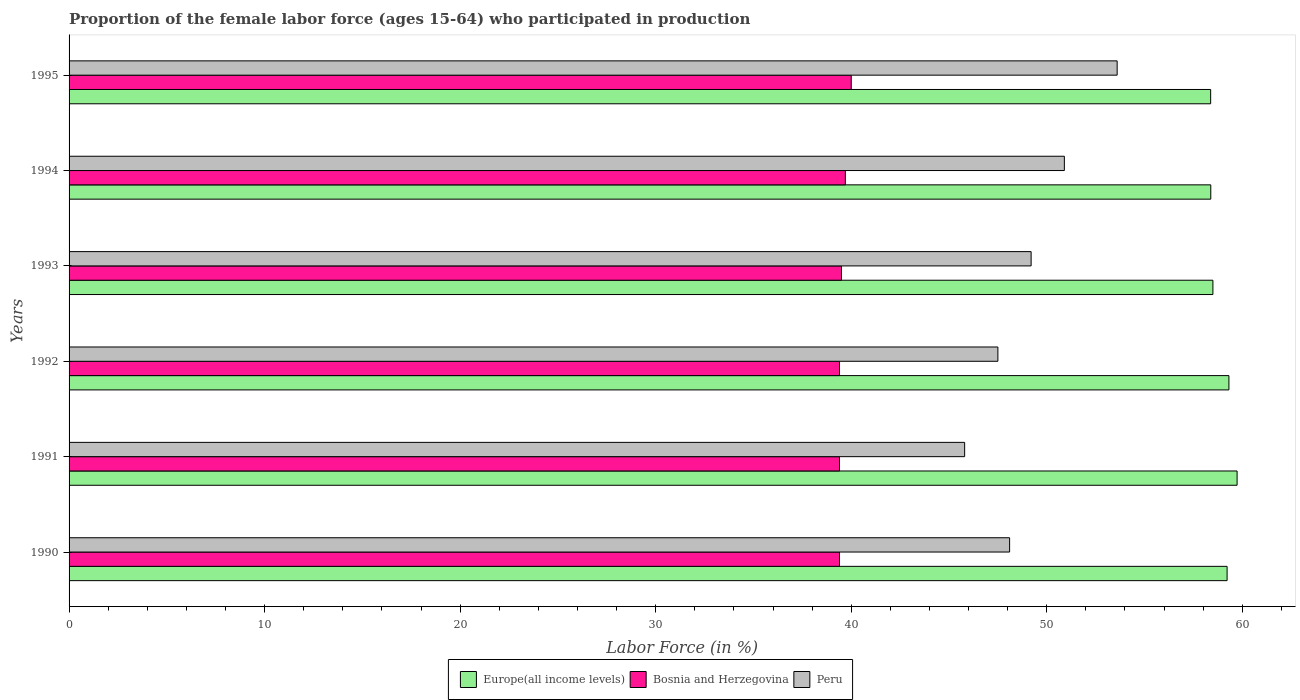How many different coloured bars are there?
Offer a very short reply. 3. How many groups of bars are there?
Ensure brevity in your answer.  6. Are the number of bars on each tick of the Y-axis equal?
Make the answer very short. Yes. How many bars are there on the 1st tick from the top?
Give a very brief answer. 3. What is the proportion of the female labor force who participated in production in Europe(all income levels) in 1993?
Ensure brevity in your answer.  58.5. Across all years, what is the maximum proportion of the female labor force who participated in production in Europe(all income levels)?
Offer a very short reply. 59.73. Across all years, what is the minimum proportion of the female labor force who participated in production in Bosnia and Herzegovina?
Keep it short and to the point. 39.4. In which year was the proportion of the female labor force who participated in production in Bosnia and Herzegovina minimum?
Offer a terse response. 1990. What is the total proportion of the female labor force who participated in production in Europe(all income levels) in the graph?
Offer a terse response. 353.54. What is the difference between the proportion of the female labor force who participated in production in Europe(all income levels) in 1992 and that in 1995?
Your answer should be very brief. 0.93. What is the difference between the proportion of the female labor force who participated in production in Peru in 1992 and the proportion of the female labor force who participated in production in Bosnia and Herzegovina in 1991?
Provide a short and direct response. 8.1. What is the average proportion of the female labor force who participated in production in Bosnia and Herzegovina per year?
Provide a short and direct response. 39.57. In the year 1994, what is the difference between the proportion of the female labor force who participated in production in Bosnia and Herzegovina and proportion of the female labor force who participated in production in Europe(all income levels)?
Make the answer very short. -18.69. In how many years, is the proportion of the female labor force who participated in production in Europe(all income levels) greater than 32 %?
Offer a terse response. 6. What is the ratio of the proportion of the female labor force who participated in production in Bosnia and Herzegovina in 1990 to that in 1995?
Make the answer very short. 0.99. Is the proportion of the female labor force who participated in production in Bosnia and Herzegovina in 1990 less than that in 1991?
Ensure brevity in your answer.  No. Is the difference between the proportion of the female labor force who participated in production in Bosnia and Herzegovina in 1990 and 1991 greater than the difference between the proportion of the female labor force who participated in production in Europe(all income levels) in 1990 and 1991?
Provide a short and direct response. Yes. What is the difference between the highest and the second highest proportion of the female labor force who participated in production in Europe(all income levels)?
Ensure brevity in your answer.  0.42. What is the difference between the highest and the lowest proportion of the female labor force who participated in production in Peru?
Your answer should be compact. 7.8. Is the sum of the proportion of the female labor force who participated in production in Peru in 1994 and 1995 greater than the maximum proportion of the female labor force who participated in production in Bosnia and Herzegovina across all years?
Provide a succinct answer. Yes. What does the 1st bar from the top in 1992 represents?
Offer a terse response. Peru. What does the 2nd bar from the bottom in 1990 represents?
Offer a very short reply. Bosnia and Herzegovina. How many bars are there?
Provide a short and direct response. 18. Are all the bars in the graph horizontal?
Your response must be concise. Yes. How many years are there in the graph?
Offer a terse response. 6. What is the difference between two consecutive major ticks on the X-axis?
Your answer should be very brief. 10. Does the graph contain any zero values?
Provide a short and direct response. No. What is the title of the graph?
Keep it short and to the point. Proportion of the female labor force (ages 15-64) who participated in production. Does "East Asia (developing only)" appear as one of the legend labels in the graph?
Provide a succinct answer. No. What is the label or title of the Y-axis?
Your response must be concise. Years. What is the Labor Force (in %) in Europe(all income levels) in 1990?
Your answer should be compact. 59.22. What is the Labor Force (in %) in Bosnia and Herzegovina in 1990?
Provide a short and direct response. 39.4. What is the Labor Force (in %) in Peru in 1990?
Offer a terse response. 48.1. What is the Labor Force (in %) of Europe(all income levels) in 1991?
Give a very brief answer. 59.73. What is the Labor Force (in %) in Bosnia and Herzegovina in 1991?
Your answer should be very brief. 39.4. What is the Labor Force (in %) in Peru in 1991?
Offer a terse response. 45.8. What is the Labor Force (in %) of Europe(all income levels) in 1992?
Your answer should be compact. 59.32. What is the Labor Force (in %) in Bosnia and Herzegovina in 1992?
Offer a very short reply. 39.4. What is the Labor Force (in %) of Peru in 1992?
Your response must be concise. 47.5. What is the Labor Force (in %) in Europe(all income levels) in 1993?
Keep it short and to the point. 58.5. What is the Labor Force (in %) of Bosnia and Herzegovina in 1993?
Make the answer very short. 39.5. What is the Labor Force (in %) of Peru in 1993?
Your answer should be compact. 49.2. What is the Labor Force (in %) of Europe(all income levels) in 1994?
Provide a succinct answer. 58.39. What is the Labor Force (in %) in Bosnia and Herzegovina in 1994?
Your answer should be compact. 39.7. What is the Labor Force (in %) of Peru in 1994?
Offer a terse response. 50.9. What is the Labor Force (in %) of Europe(all income levels) in 1995?
Provide a succinct answer. 58.38. What is the Labor Force (in %) in Peru in 1995?
Provide a short and direct response. 53.6. Across all years, what is the maximum Labor Force (in %) of Europe(all income levels)?
Keep it short and to the point. 59.73. Across all years, what is the maximum Labor Force (in %) of Bosnia and Herzegovina?
Ensure brevity in your answer.  40. Across all years, what is the maximum Labor Force (in %) of Peru?
Make the answer very short. 53.6. Across all years, what is the minimum Labor Force (in %) in Europe(all income levels)?
Provide a short and direct response. 58.38. Across all years, what is the minimum Labor Force (in %) of Bosnia and Herzegovina?
Keep it short and to the point. 39.4. Across all years, what is the minimum Labor Force (in %) of Peru?
Ensure brevity in your answer.  45.8. What is the total Labor Force (in %) of Europe(all income levels) in the graph?
Keep it short and to the point. 353.54. What is the total Labor Force (in %) in Bosnia and Herzegovina in the graph?
Ensure brevity in your answer.  237.4. What is the total Labor Force (in %) in Peru in the graph?
Give a very brief answer. 295.1. What is the difference between the Labor Force (in %) in Europe(all income levels) in 1990 and that in 1991?
Your response must be concise. -0.51. What is the difference between the Labor Force (in %) of Europe(all income levels) in 1990 and that in 1992?
Offer a very short reply. -0.09. What is the difference between the Labor Force (in %) in Bosnia and Herzegovina in 1990 and that in 1992?
Provide a succinct answer. 0. What is the difference between the Labor Force (in %) of Europe(all income levels) in 1990 and that in 1993?
Give a very brief answer. 0.73. What is the difference between the Labor Force (in %) of Bosnia and Herzegovina in 1990 and that in 1993?
Provide a succinct answer. -0.1. What is the difference between the Labor Force (in %) in Peru in 1990 and that in 1993?
Give a very brief answer. -1.1. What is the difference between the Labor Force (in %) of Europe(all income levels) in 1990 and that in 1994?
Your answer should be compact. 0.83. What is the difference between the Labor Force (in %) of Europe(all income levels) in 1990 and that in 1995?
Your answer should be very brief. 0.84. What is the difference between the Labor Force (in %) of Peru in 1990 and that in 1995?
Keep it short and to the point. -5.5. What is the difference between the Labor Force (in %) of Europe(all income levels) in 1991 and that in 1992?
Your answer should be very brief. 0.42. What is the difference between the Labor Force (in %) of Bosnia and Herzegovina in 1991 and that in 1992?
Offer a terse response. 0. What is the difference between the Labor Force (in %) in Peru in 1991 and that in 1992?
Your answer should be very brief. -1.7. What is the difference between the Labor Force (in %) of Europe(all income levels) in 1991 and that in 1993?
Offer a very short reply. 1.24. What is the difference between the Labor Force (in %) in Peru in 1991 and that in 1993?
Offer a terse response. -3.4. What is the difference between the Labor Force (in %) in Europe(all income levels) in 1991 and that in 1994?
Provide a succinct answer. 1.35. What is the difference between the Labor Force (in %) in Bosnia and Herzegovina in 1991 and that in 1994?
Make the answer very short. -0.3. What is the difference between the Labor Force (in %) of Europe(all income levels) in 1991 and that in 1995?
Your answer should be compact. 1.35. What is the difference between the Labor Force (in %) of Europe(all income levels) in 1992 and that in 1993?
Provide a short and direct response. 0.82. What is the difference between the Labor Force (in %) in Bosnia and Herzegovina in 1992 and that in 1993?
Your answer should be compact. -0.1. What is the difference between the Labor Force (in %) of Peru in 1992 and that in 1993?
Ensure brevity in your answer.  -1.7. What is the difference between the Labor Force (in %) of Europe(all income levels) in 1992 and that in 1994?
Offer a very short reply. 0.93. What is the difference between the Labor Force (in %) in Peru in 1992 and that in 1994?
Ensure brevity in your answer.  -3.4. What is the difference between the Labor Force (in %) in Europe(all income levels) in 1992 and that in 1995?
Provide a short and direct response. 0.93. What is the difference between the Labor Force (in %) in Bosnia and Herzegovina in 1992 and that in 1995?
Your response must be concise. -0.6. What is the difference between the Labor Force (in %) in Europe(all income levels) in 1993 and that in 1994?
Make the answer very short. 0.11. What is the difference between the Labor Force (in %) of Europe(all income levels) in 1993 and that in 1995?
Offer a very short reply. 0.12. What is the difference between the Labor Force (in %) of Bosnia and Herzegovina in 1993 and that in 1995?
Give a very brief answer. -0.5. What is the difference between the Labor Force (in %) of Europe(all income levels) in 1994 and that in 1995?
Provide a succinct answer. 0.01. What is the difference between the Labor Force (in %) in Peru in 1994 and that in 1995?
Your answer should be compact. -2.7. What is the difference between the Labor Force (in %) in Europe(all income levels) in 1990 and the Labor Force (in %) in Bosnia and Herzegovina in 1991?
Your answer should be very brief. 19.82. What is the difference between the Labor Force (in %) in Europe(all income levels) in 1990 and the Labor Force (in %) in Peru in 1991?
Provide a short and direct response. 13.42. What is the difference between the Labor Force (in %) of Bosnia and Herzegovina in 1990 and the Labor Force (in %) of Peru in 1991?
Your answer should be very brief. -6.4. What is the difference between the Labor Force (in %) of Europe(all income levels) in 1990 and the Labor Force (in %) of Bosnia and Herzegovina in 1992?
Give a very brief answer. 19.82. What is the difference between the Labor Force (in %) of Europe(all income levels) in 1990 and the Labor Force (in %) of Peru in 1992?
Offer a very short reply. 11.72. What is the difference between the Labor Force (in %) in Europe(all income levels) in 1990 and the Labor Force (in %) in Bosnia and Herzegovina in 1993?
Make the answer very short. 19.72. What is the difference between the Labor Force (in %) of Europe(all income levels) in 1990 and the Labor Force (in %) of Peru in 1993?
Offer a very short reply. 10.02. What is the difference between the Labor Force (in %) in Bosnia and Herzegovina in 1990 and the Labor Force (in %) in Peru in 1993?
Ensure brevity in your answer.  -9.8. What is the difference between the Labor Force (in %) of Europe(all income levels) in 1990 and the Labor Force (in %) of Bosnia and Herzegovina in 1994?
Keep it short and to the point. 19.52. What is the difference between the Labor Force (in %) in Europe(all income levels) in 1990 and the Labor Force (in %) in Peru in 1994?
Your response must be concise. 8.32. What is the difference between the Labor Force (in %) in Bosnia and Herzegovina in 1990 and the Labor Force (in %) in Peru in 1994?
Offer a terse response. -11.5. What is the difference between the Labor Force (in %) of Europe(all income levels) in 1990 and the Labor Force (in %) of Bosnia and Herzegovina in 1995?
Ensure brevity in your answer.  19.22. What is the difference between the Labor Force (in %) of Europe(all income levels) in 1990 and the Labor Force (in %) of Peru in 1995?
Your answer should be very brief. 5.62. What is the difference between the Labor Force (in %) of Europe(all income levels) in 1991 and the Labor Force (in %) of Bosnia and Herzegovina in 1992?
Provide a short and direct response. 20.33. What is the difference between the Labor Force (in %) in Europe(all income levels) in 1991 and the Labor Force (in %) in Peru in 1992?
Offer a terse response. 12.23. What is the difference between the Labor Force (in %) of Bosnia and Herzegovina in 1991 and the Labor Force (in %) of Peru in 1992?
Provide a succinct answer. -8.1. What is the difference between the Labor Force (in %) of Europe(all income levels) in 1991 and the Labor Force (in %) of Bosnia and Herzegovina in 1993?
Offer a very short reply. 20.23. What is the difference between the Labor Force (in %) of Europe(all income levels) in 1991 and the Labor Force (in %) of Peru in 1993?
Ensure brevity in your answer.  10.53. What is the difference between the Labor Force (in %) of Europe(all income levels) in 1991 and the Labor Force (in %) of Bosnia and Herzegovina in 1994?
Your response must be concise. 20.03. What is the difference between the Labor Force (in %) in Europe(all income levels) in 1991 and the Labor Force (in %) in Peru in 1994?
Offer a terse response. 8.83. What is the difference between the Labor Force (in %) of Europe(all income levels) in 1991 and the Labor Force (in %) of Bosnia and Herzegovina in 1995?
Your response must be concise. 19.73. What is the difference between the Labor Force (in %) in Europe(all income levels) in 1991 and the Labor Force (in %) in Peru in 1995?
Ensure brevity in your answer.  6.13. What is the difference between the Labor Force (in %) of Bosnia and Herzegovina in 1991 and the Labor Force (in %) of Peru in 1995?
Your answer should be compact. -14.2. What is the difference between the Labor Force (in %) of Europe(all income levels) in 1992 and the Labor Force (in %) of Bosnia and Herzegovina in 1993?
Make the answer very short. 19.82. What is the difference between the Labor Force (in %) of Europe(all income levels) in 1992 and the Labor Force (in %) of Peru in 1993?
Ensure brevity in your answer.  10.12. What is the difference between the Labor Force (in %) of Europe(all income levels) in 1992 and the Labor Force (in %) of Bosnia and Herzegovina in 1994?
Provide a succinct answer. 19.62. What is the difference between the Labor Force (in %) in Europe(all income levels) in 1992 and the Labor Force (in %) in Peru in 1994?
Make the answer very short. 8.42. What is the difference between the Labor Force (in %) in Bosnia and Herzegovina in 1992 and the Labor Force (in %) in Peru in 1994?
Keep it short and to the point. -11.5. What is the difference between the Labor Force (in %) of Europe(all income levels) in 1992 and the Labor Force (in %) of Bosnia and Herzegovina in 1995?
Offer a terse response. 19.32. What is the difference between the Labor Force (in %) of Europe(all income levels) in 1992 and the Labor Force (in %) of Peru in 1995?
Give a very brief answer. 5.72. What is the difference between the Labor Force (in %) of Europe(all income levels) in 1993 and the Labor Force (in %) of Bosnia and Herzegovina in 1994?
Give a very brief answer. 18.8. What is the difference between the Labor Force (in %) of Europe(all income levels) in 1993 and the Labor Force (in %) of Peru in 1994?
Offer a very short reply. 7.6. What is the difference between the Labor Force (in %) in Europe(all income levels) in 1993 and the Labor Force (in %) in Bosnia and Herzegovina in 1995?
Offer a terse response. 18.5. What is the difference between the Labor Force (in %) in Europe(all income levels) in 1993 and the Labor Force (in %) in Peru in 1995?
Provide a short and direct response. 4.9. What is the difference between the Labor Force (in %) of Bosnia and Herzegovina in 1993 and the Labor Force (in %) of Peru in 1995?
Your response must be concise. -14.1. What is the difference between the Labor Force (in %) of Europe(all income levels) in 1994 and the Labor Force (in %) of Bosnia and Herzegovina in 1995?
Give a very brief answer. 18.39. What is the difference between the Labor Force (in %) of Europe(all income levels) in 1994 and the Labor Force (in %) of Peru in 1995?
Your answer should be very brief. 4.79. What is the difference between the Labor Force (in %) in Bosnia and Herzegovina in 1994 and the Labor Force (in %) in Peru in 1995?
Offer a very short reply. -13.9. What is the average Labor Force (in %) in Europe(all income levels) per year?
Offer a terse response. 58.92. What is the average Labor Force (in %) of Bosnia and Herzegovina per year?
Ensure brevity in your answer.  39.57. What is the average Labor Force (in %) of Peru per year?
Provide a succinct answer. 49.18. In the year 1990, what is the difference between the Labor Force (in %) in Europe(all income levels) and Labor Force (in %) in Bosnia and Herzegovina?
Your answer should be compact. 19.82. In the year 1990, what is the difference between the Labor Force (in %) in Europe(all income levels) and Labor Force (in %) in Peru?
Ensure brevity in your answer.  11.12. In the year 1991, what is the difference between the Labor Force (in %) of Europe(all income levels) and Labor Force (in %) of Bosnia and Herzegovina?
Provide a succinct answer. 20.33. In the year 1991, what is the difference between the Labor Force (in %) of Europe(all income levels) and Labor Force (in %) of Peru?
Make the answer very short. 13.93. In the year 1991, what is the difference between the Labor Force (in %) of Bosnia and Herzegovina and Labor Force (in %) of Peru?
Your response must be concise. -6.4. In the year 1992, what is the difference between the Labor Force (in %) in Europe(all income levels) and Labor Force (in %) in Bosnia and Herzegovina?
Provide a short and direct response. 19.92. In the year 1992, what is the difference between the Labor Force (in %) of Europe(all income levels) and Labor Force (in %) of Peru?
Your answer should be compact. 11.82. In the year 1993, what is the difference between the Labor Force (in %) in Europe(all income levels) and Labor Force (in %) in Bosnia and Herzegovina?
Your answer should be very brief. 19. In the year 1993, what is the difference between the Labor Force (in %) in Europe(all income levels) and Labor Force (in %) in Peru?
Your response must be concise. 9.3. In the year 1993, what is the difference between the Labor Force (in %) of Bosnia and Herzegovina and Labor Force (in %) of Peru?
Offer a terse response. -9.7. In the year 1994, what is the difference between the Labor Force (in %) of Europe(all income levels) and Labor Force (in %) of Bosnia and Herzegovina?
Your response must be concise. 18.69. In the year 1994, what is the difference between the Labor Force (in %) in Europe(all income levels) and Labor Force (in %) in Peru?
Provide a short and direct response. 7.49. In the year 1994, what is the difference between the Labor Force (in %) of Bosnia and Herzegovina and Labor Force (in %) of Peru?
Keep it short and to the point. -11.2. In the year 1995, what is the difference between the Labor Force (in %) of Europe(all income levels) and Labor Force (in %) of Bosnia and Herzegovina?
Offer a very short reply. 18.38. In the year 1995, what is the difference between the Labor Force (in %) of Europe(all income levels) and Labor Force (in %) of Peru?
Offer a very short reply. 4.78. In the year 1995, what is the difference between the Labor Force (in %) of Bosnia and Herzegovina and Labor Force (in %) of Peru?
Provide a short and direct response. -13.6. What is the ratio of the Labor Force (in %) in Europe(all income levels) in 1990 to that in 1991?
Offer a terse response. 0.99. What is the ratio of the Labor Force (in %) of Peru in 1990 to that in 1991?
Make the answer very short. 1.05. What is the ratio of the Labor Force (in %) in Peru in 1990 to that in 1992?
Offer a very short reply. 1.01. What is the ratio of the Labor Force (in %) in Europe(all income levels) in 1990 to that in 1993?
Offer a very short reply. 1.01. What is the ratio of the Labor Force (in %) in Bosnia and Herzegovina in 1990 to that in 1993?
Offer a terse response. 1. What is the ratio of the Labor Force (in %) of Peru in 1990 to that in 1993?
Your answer should be very brief. 0.98. What is the ratio of the Labor Force (in %) of Europe(all income levels) in 1990 to that in 1994?
Provide a succinct answer. 1.01. What is the ratio of the Labor Force (in %) of Peru in 1990 to that in 1994?
Offer a terse response. 0.94. What is the ratio of the Labor Force (in %) in Europe(all income levels) in 1990 to that in 1995?
Ensure brevity in your answer.  1.01. What is the ratio of the Labor Force (in %) of Bosnia and Herzegovina in 1990 to that in 1995?
Your response must be concise. 0.98. What is the ratio of the Labor Force (in %) in Peru in 1990 to that in 1995?
Make the answer very short. 0.9. What is the ratio of the Labor Force (in %) in Europe(all income levels) in 1991 to that in 1992?
Keep it short and to the point. 1.01. What is the ratio of the Labor Force (in %) of Peru in 1991 to that in 1992?
Offer a terse response. 0.96. What is the ratio of the Labor Force (in %) of Europe(all income levels) in 1991 to that in 1993?
Your answer should be very brief. 1.02. What is the ratio of the Labor Force (in %) of Peru in 1991 to that in 1993?
Provide a succinct answer. 0.93. What is the ratio of the Labor Force (in %) of Europe(all income levels) in 1991 to that in 1994?
Your response must be concise. 1.02. What is the ratio of the Labor Force (in %) of Bosnia and Herzegovina in 1991 to that in 1994?
Provide a succinct answer. 0.99. What is the ratio of the Labor Force (in %) in Peru in 1991 to that in 1994?
Offer a very short reply. 0.9. What is the ratio of the Labor Force (in %) in Europe(all income levels) in 1991 to that in 1995?
Keep it short and to the point. 1.02. What is the ratio of the Labor Force (in %) in Bosnia and Herzegovina in 1991 to that in 1995?
Give a very brief answer. 0.98. What is the ratio of the Labor Force (in %) of Peru in 1991 to that in 1995?
Provide a succinct answer. 0.85. What is the ratio of the Labor Force (in %) in Bosnia and Herzegovina in 1992 to that in 1993?
Your answer should be compact. 1. What is the ratio of the Labor Force (in %) in Peru in 1992 to that in 1993?
Provide a short and direct response. 0.97. What is the ratio of the Labor Force (in %) of Europe(all income levels) in 1992 to that in 1994?
Provide a succinct answer. 1.02. What is the ratio of the Labor Force (in %) in Peru in 1992 to that in 1994?
Make the answer very short. 0.93. What is the ratio of the Labor Force (in %) of Europe(all income levels) in 1992 to that in 1995?
Ensure brevity in your answer.  1.02. What is the ratio of the Labor Force (in %) of Peru in 1992 to that in 1995?
Your answer should be very brief. 0.89. What is the ratio of the Labor Force (in %) of Peru in 1993 to that in 1994?
Make the answer very short. 0.97. What is the ratio of the Labor Force (in %) in Bosnia and Herzegovina in 1993 to that in 1995?
Offer a very short reply. 0.99. What is the ratio of the Labor Force (in %) in Peru in 1993 to that in 1995?
Your response must be concise. 0.92. What is the ratio of the Labor Force (in %) of Bosnia and Herzegovina in 1994 to that in 1995?
Your answer should be very brief. 0.99. What is the ratio of the Labor Force (in %) in Peru in 1994 to that in 1995?
Your answer should be very brief. 0.95. What is the difference between the highest and the second highest Labor Force (in %) in Europe(all income levels)?
Provide a succinct answer. 0.42. What is the difference between the highest and the second highest Labor Force (in %) of Bosnia and Herzegovina?
Give a very brief answer. 0.3. What is the difference between the highest and the second highest Labor Force (in %) of Peru?
Ensure brevity in your answer.  2.7. What is the difference between the highest and the lowest Labor Force (in %) of Europe(all income levels)?
Make the answer very short. 1.35. What is the difference between the highest and the lowest Labor Force (in %) in Peru?
Keep it short and to the point. 7.8. 